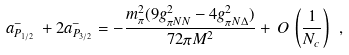<formula> <loc_0><loc_0><loc_500><loc_500>a ^ { - } _ { P _ { 1 / 2 } } \, + 2 a ^ { - } _ { P _ { 3 / 2 } } = - \frac { m _ { \pi } ^ { 2 } ( 9 g _ { \pi N N } ^ { 2 } - 4 g _ { \pi N \Delta } ^ { 2 } ) } { 7 2 \pi M ^ { 2 } } + \, O \, \left ( \frac { 1 } { N _ { c } } \right ) \ ,</formula> 